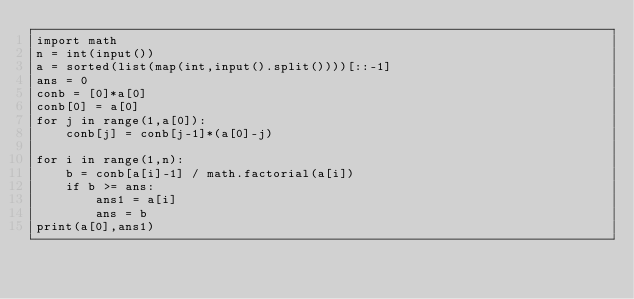Convert code to text. <code><loc_0><loc_0><loc_500><loc_500><_Python_>import math
n = int(input())
a = sorted(list(map(int,input().split())))[::-1]
ans = 0
conb = [0]*a[0]
conb[0] = a[0]
for j in range(1,a[0]):
    conb[j] = conb[j-1]*(a[0]-j)

for i in range(1,n):
    b = conb[a[i]-1] / math.factorial(a[i])
    if b >= ans:
        ans1 = a[i]
        ans = b
print(a[0],ans1)</code> 